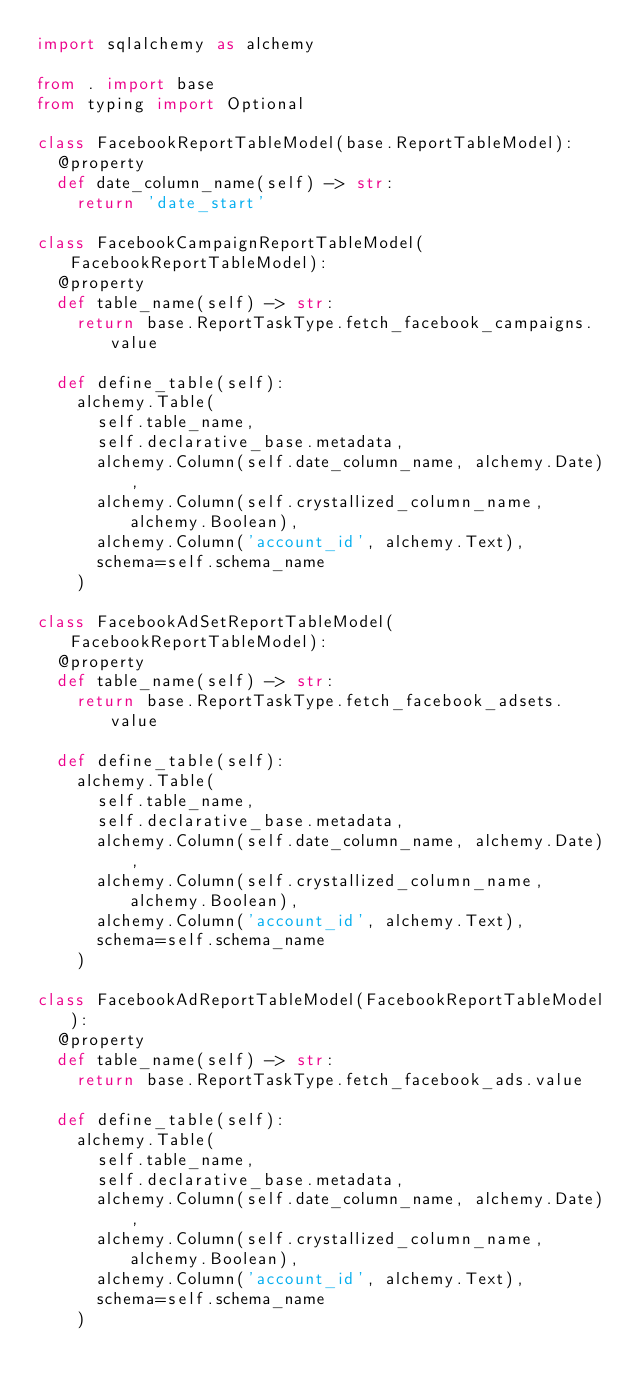Convert code to text. <code><loc_0><loc_0><loc_500><loc_500><_Python_>import sqlalchemy as alchemy

from . import base
from typing import Optional

class FacebookReportTableModel(base.ReportTableModel):
  @property
  def date_column_name(self) -> str:
    return 'date_start'

class FacebookCampaignReportTableModel(FacebookReportTableModel):
  @property
  def table_name(self) -> str:
    return base.ReportTaskType.fetch_facebook_campaigns.value

  def define_table(self):
    alchemy.Table(
      self.table_name,
      self.declarative_base.metadata,
      alchemy.Column(self.date_column_name, alchemy.Date),
      alchemy.Column(self.crystallized_column_name, alchemy.Boolean),
      alchemy.Column('account_id', alchemy.Text),
      schema=self.schema_name
    )

class FacebookAdSetReportTableModel(FacebookReportTableModel):
  @property
  def table_name(self) -> str:
    return base.ReportTaskType.fetch_facebook_adsets.value

  def define_table(self):
    alchemy.Table(
      self.table_name,
      self.declarative_base.metadata,
      alchemy.Column(self.date_column_name, alchemy.Date),
      alchemy.Column(self.crystallized_column_name, alchemy.Boolean),
      alchemy.Column('account_id', alchemy.Text),
      schema=self.schema_name
    )

class FacebookAdReportTableModel(FacebookReportTableModel):
  @property
  def table_name(self) -> str:
    return base.ReportTaskType.fetch_facebook_ads.value

  def define_table(self):
    alchemy.Table(
      self.table_name,
      self.declarative_base.metadata,
      alchemy.Column(self.date_column_name, alchemy.Date),
      alchemy.Column(self.crystallized_column_name, alchemy.Boolean),
      alchemy.Column('account_id', alchemy.Text),
      schema=self.schema_name
    )
</code> 